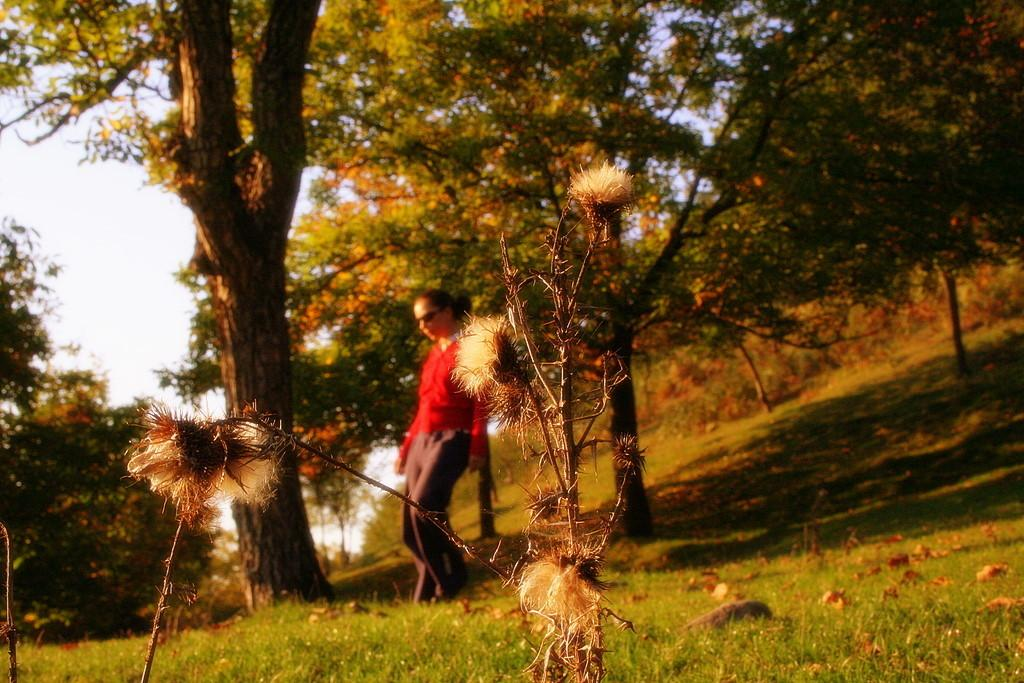Who or what is present in the image? There is a person in the image. What type of natural environment is depicted in the image? There are trees, grass, and rocks at the bottom of the image, suggesting a natural setting. What can be seen in the background of the image? The sky is visible in the background of the image. What other objects are present in the image besides the person? There are other objects in the image, but their specific nature is not mentioned in the facts. What type of milk can be seen in the image? There is no milk present in the image. How many necks can be seen on the person in the image? The facts provided do not mention the number of necks on the person in the image, and it is not possible to determine this from the image alone. 